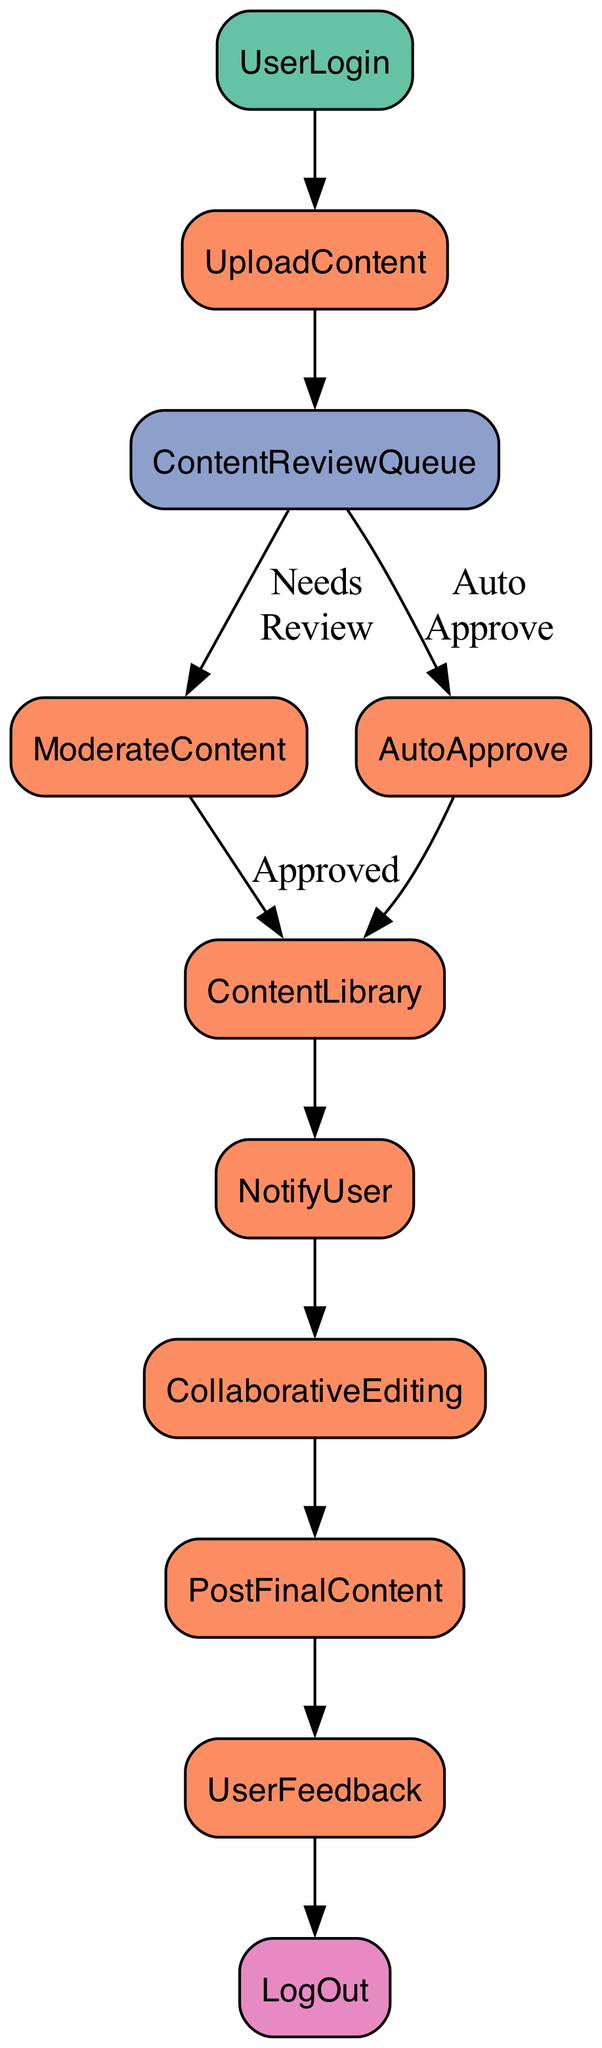What is the first step in the function flow? The diagram starts with the "UserLogin" node, which indicates the initial action taken by users to enter the collaborative writing platform.
Answer: UserLogin How many total processes are present in the flow chart? Counting the nodes labeled as "Process", there are six: "UploadContent," "ModerateContent," "AutoApprove," "ContentLibrary," "NotifyUser," and "CollaborativeEditing."
Answer: Six What happens if the content does not need moderation? If the content does not need moderation, the process moves directly from "ContentReviewQueue" to "AutoApprove," bypassing any moderation.
Answer: AutoApprove Which node follows the "NotifyUser" process? After the "NotifyUser" process, the flow leads to the "CollaborativeEditing" node, indicating the next step after users are informed.
Answer: CollaborativeEditing What is the final output of the function flow? The last step in the flow chart, following "UserFeedback," is "LogOut," which signifies the end of a user's interaction with the platform.
Answer: LogOut How many decisions are represented in the diagram? The diagram has one decision node labeled "ContentReviewQueue," which determines whether the content needs moderation or can be auto-approved.
Answer: One Which process handles content that requires moderation? The "ModerateContent" process is responsible for reviewing and approving or rejecting content that is flagged as needing moderation.
Answer: ModerateContent What is the relationship between "AutoApprove" and "ContentLibrary"? The process of "AutoApprove," when completed, directs the flow to "ContentLibrary," indicating that auto-approved content is stored there.
Answer: Directed to ContentLibrary 